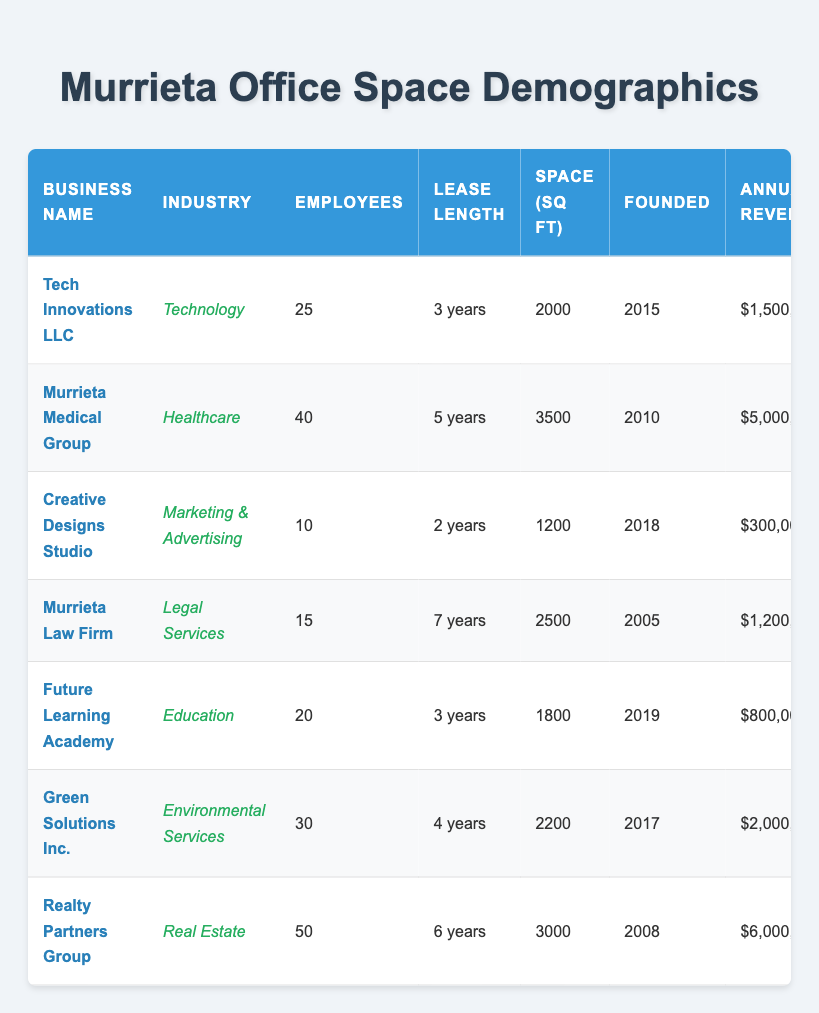What is the highest annual revenue reported by a business in Murrieta? The highest annual revenue can be found by scanning through the "Annual Revenue" column in the table. The highest figure is $6,000,000 reported by Realty Partners Group.
Answer: $6,000,000 Which industry has the most employees on average? To find the average number of employees for each industry, we need to calculate the average based on the number of employees in each business across their respective industries. The average calculations are: Technology (25), Healthcare (40), Marketing & Advertising (10), Legal Services (15), Education (20), Environmental Services (30), Real Estate (50). The averages are 25, 40, 10, 15, 20, 30, and 50. Therefore, the Real Estate industry has the most employees on average.
Answer: Real Estate Is there a business founded after 2015 that has a lease length of 5 years or more? By reviewing the "Year Founded" and "Average Lease Length" columns, we see that Murrieta Medical Group, founded in 2010 with a lease length of 5 years, is the only business with a lease length of 5 years or more but was founded before 2015. Therefore, there are no businesses founded after 2015 with a lease length of 5 years or more.
Answer: No What is the total office space in square feet occupied by businesses in the healthcare and education sectors? We need to sum the "Office Space Square Feet" for businesses in the healthcare (Murrieta Medical Group - 3500 sq ft) and education (Future Learning Academy - 1800 sq ft) sectors. Therefore, 3500 + 1800 = 5300.
Answer: 5300 sq ft Which location has the smallest office space? From the "Office Space Square Feet" column, we identify that Creative Designs Studio has the smallest office space, which occupies 1200 sq ft located in Murrieta Business Park.
Answer: Murrieta Business Park Are there more businesses in the North or South of Murrieta? Reviewing the table, North Murrieta has one business (Green Solutions Inc.) and East Murrieta has one (Murrieta Medical Group), Downtown Murrieta counts as central and does not belong to either direction, while the West Murrieta has one business (Murrieta Law Firm). Therefore, there is no clear majority toward North or South.
Answer: Equal What is the median number of employees among all the businesses? To find the median, we first list the number of employees: 25, 40, 10, 15, 20, 30, 50. Arranging these values in ascending order gives us: 10, 15, 20, 25, 30, 40, 50. The median is the middle value, which is 25 (4th number in a sorted list of 7).
Answer: 25 Which industry occupies the largest average office space? Calculating the average office space for each industry: Technology (2000 sq ft), Healthcare (3500 sq ft), Marketing & Advertising (1200 sq ft), Legal Services (2500 sq ft), Education (1800 sq ft), Environmental Services (2200 sq ft), and Real Estate (3000 sq ft). The highest average is in the Healthcare industry with 3500 sq ft.
Answer: Healthcare How many years does the average lease last among all listed businesses? To find the average lease length, convert the lease lengths to years in numerical form: Technology (3), Healthcare (5), Marketing & Advertising (2), Legal Services (7), Education (3), Environmental Services (4), Real Estate (6). Summing these gives 30 years across 7 businesses, so the average is 30/7 = approximately 4.29 years.
Answer: Approximately 4.29 years Is there a business with an annual revenue exceeding $4 million? Looking through the "Annual Revenue" column, Murrieta Medical Group ($5,000,000) and Realty Partners Group ($6,000,000) both exceed $4 million, confirming that at least one business exists.
Answer: Yes 